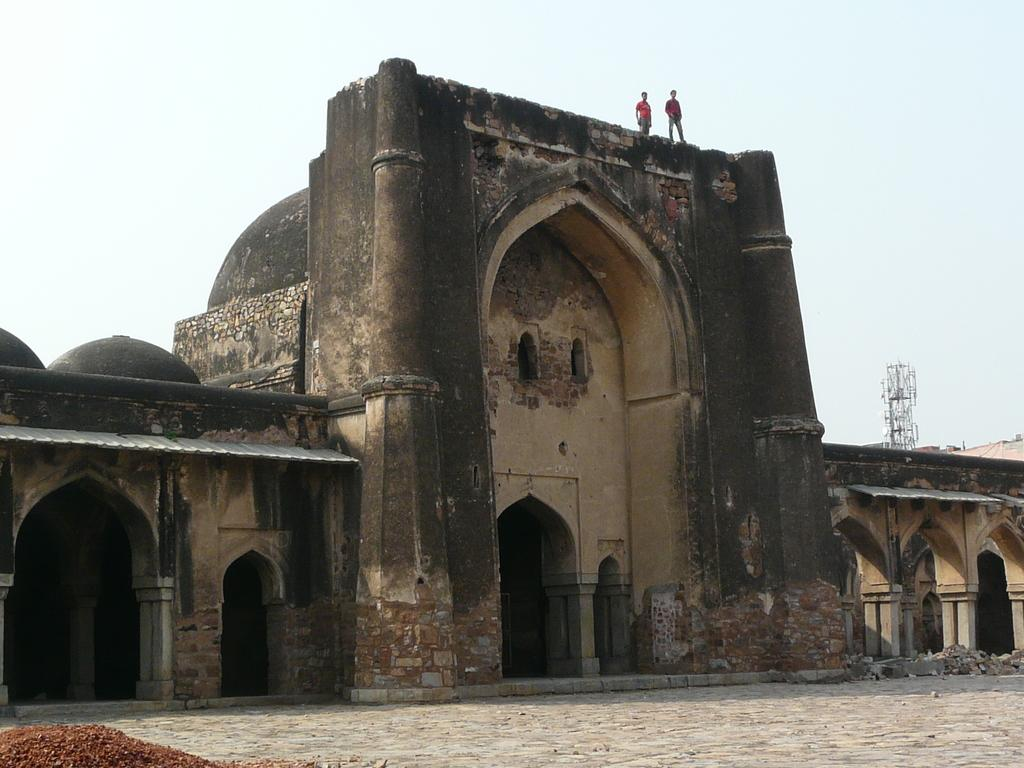What type of structure is depicted in the image? There is an old architecture building in the image. Are there any people present in the image? Yes, two people are standing on the building. What can be seen behind the building? There is a transmission tower behind the building. What is visible in the background of the image? The sky is visible in the image. What type of tin is being used by the doctor on the branch in the image? There is no tin, doctor, or branch present in the image. 